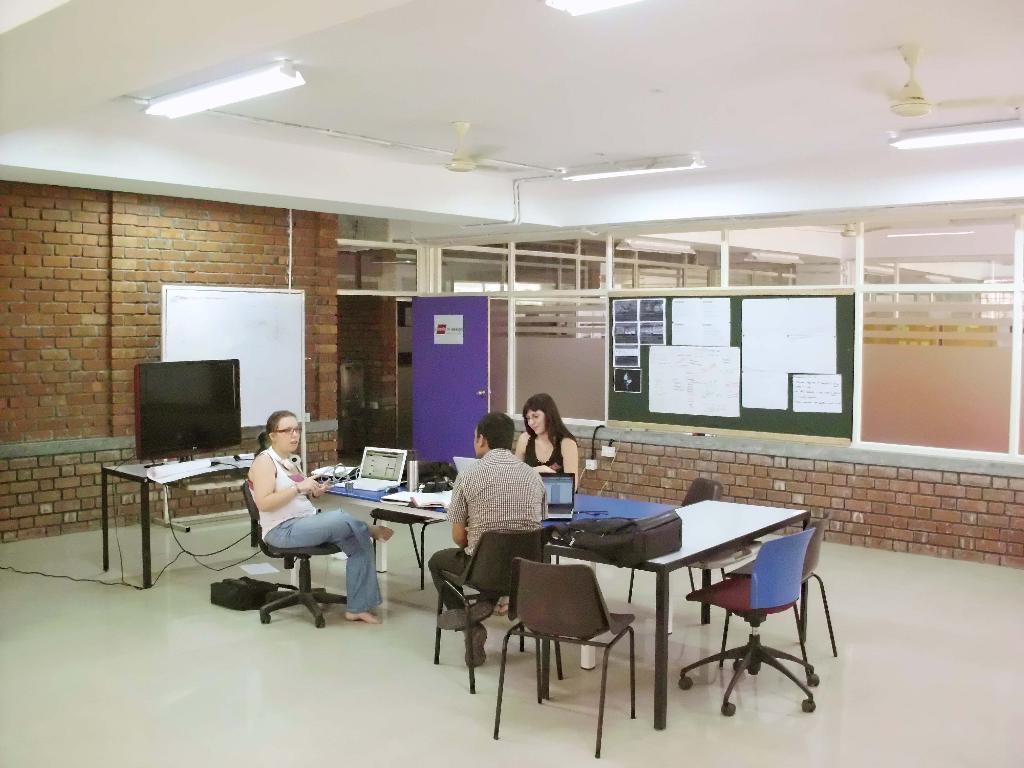Can you describe this image briefly? Her we can see a group of people are sitting on the chair, and in front here is the table and laptop and some objects on it, and here is the television, and at back here is the wall made of bricks, and here is the board, and here are the lights. 